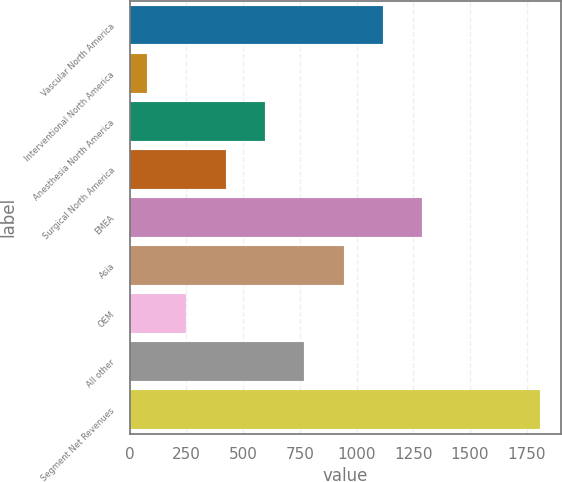Convert chart. <chart><loc_0><loc_0><loc_500><loc_500><bar_chart><fcel>Vascular North America<fcel>Interventional North America<fcel>Anesthesia North America<fcel>Surgical North America<fcel>EMEA<fcel>Asia<fcel>OEM<fcel>All other<fcel>Segment Net Revenues<nl><fcel>1115.9<fcel>75.2<fcel>595.55<fcel>422.1<fcel>1289.35<fcel>942.45<fcel>248.65<fcel>769<fcel>1809.7<nl></chart> 